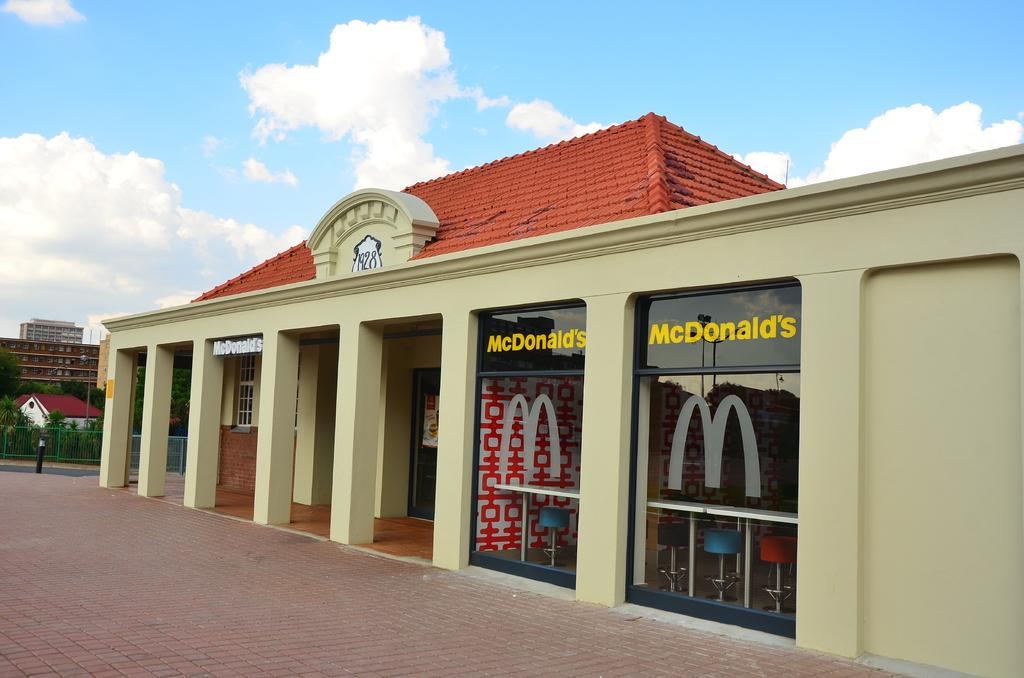Provide a one-sentence caption for the provided image. a tan and red roof mcdonalds with two windwos. 